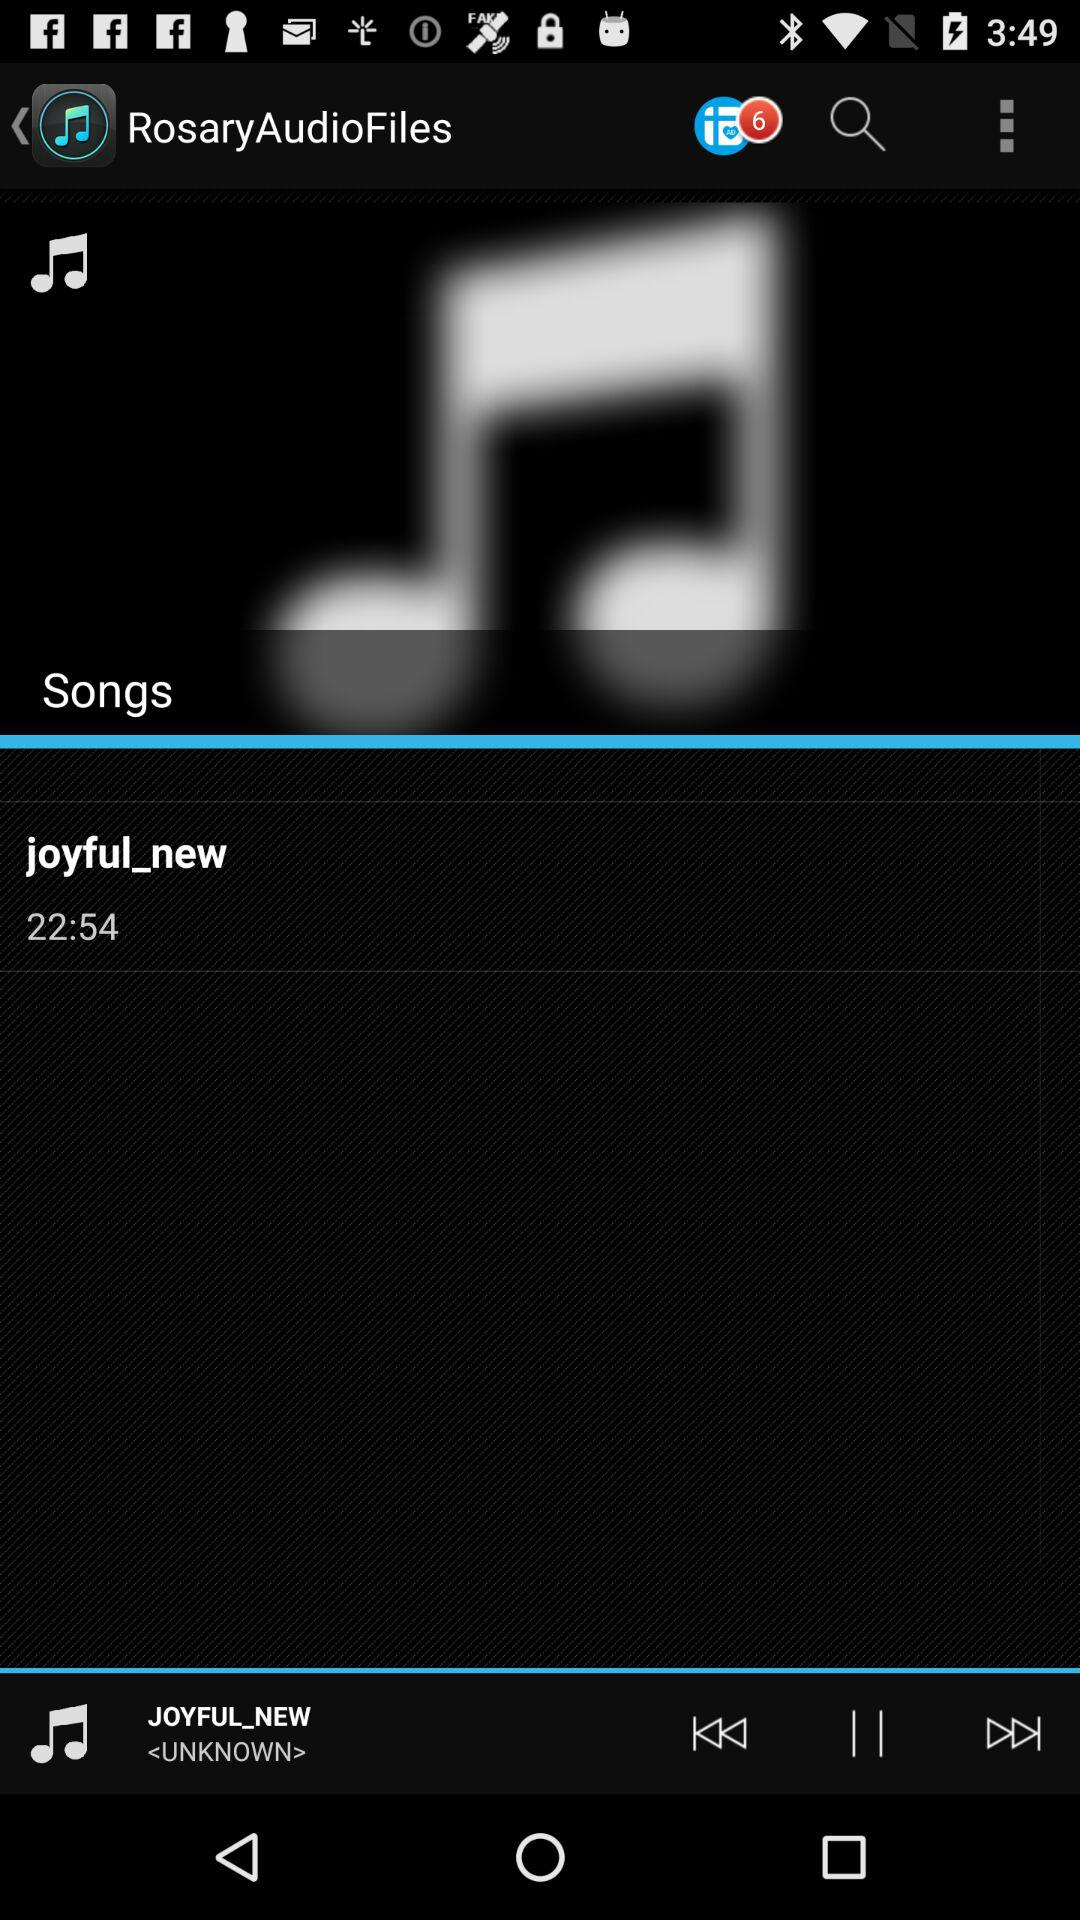What is the length of the song? The length of the song is 22:54. 